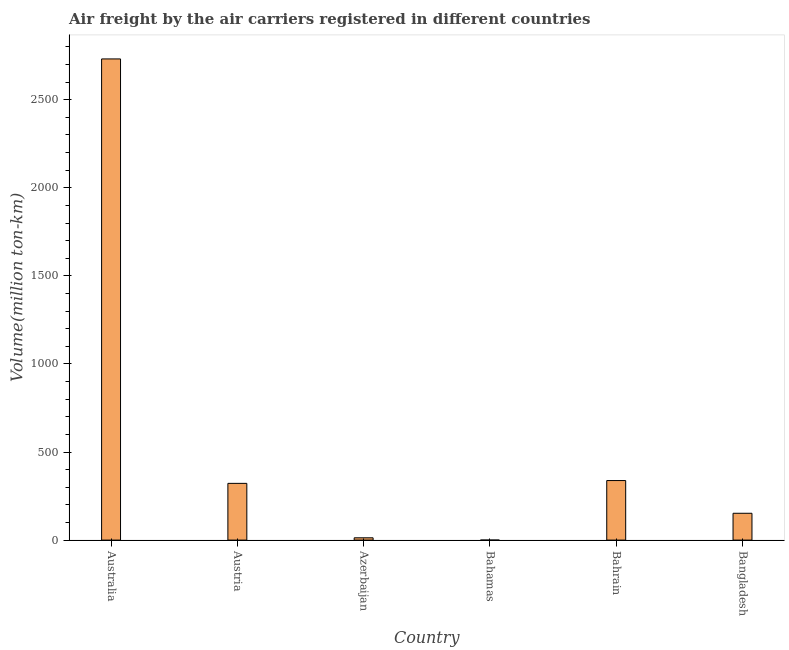Does the graph contain any zero values?
Ensure brevity in your answer.  No. What is the title of the graph?
Your response must be concise. Air freight by the air carriers registered in different countries. What is the label or title of the X-axis?
Offer a very short reply. Country. What is the label or title of the Y-axis?
Your answer should be very brief. Volume(million ton-km). What is the air freight in Azerbaijan?
Your response must be concise. 13.04. Across all countries, what is the maximum air freight?
Offer a terse response. 2731.7. Across all countries, what is the minimum air freight?
Make the answer very short. 0.12. In which country was the air freight maximum?
Provide a short and direct response. Australia. In which country was the air freight minimum?
Offer a very short reply. Bahamas. What is the sum of the air freight?
Your answer should be compact. 3557.36. What is the difference between the air freight in Azerbaijan and Bangladesh?
Your response must be concise. -139.28. What is the average air freight per country?
Your response must be concise. 592.89. What is the median air freight?
Provide a succinct answer. 237.21. What is the ratio of the air freight in Australia to that in Azerbaijan?
Ensure brevity in your answer.  209.42. Is the air freight in Australia less than that in Bahrain?
Your response must be concise. No. What is the difference between the highest and the second highest air freight?
Make the answer very short. 2393.63. What is the difference between the highest and the lowest air freight?
Make the answer very short. 2731.58. What is the difference between two consecutive major ticks on the Y-axis?
Offer a very short reply. 500. Are the values on the major ticks of Y-axis written in scientific E-notation?
Give a very brief answer. No. What is the Volume(million ton-km) in Australia?
Make the answer very short. 2731.7. What is the Volume(million ton-km) of Austria?
Provide a succinct answer. 322.1. What is the Volume(million ton-km) of Azerbaijan?
Provide a succinct answer. 13.04. What is the Volume(million ton-km) in Bahamas?
Offer a very short reply. 0.12. What is the Volume(million ton-km) of Bahrain?
Offer a terse response. 338.07. What is the Volume(million ton-km) of Bangladesh?
Your answer should be very brief. 152.32. What is the difference between the Volume(million ton-km) in Australia and Austria?
Your answer should be compact. 2409.59. What is the difference between the Volume(million ton-km) in Australia and Azerbaijan?
Make the answer very short. 2718.65. What is the difference between the Volume(million ton-km) in Australia and Bahamas?
Give a very brief answer. 2731.58. What is the difference between the Volume(million ton-km) in Australia and Bahrain?
Keep it short and to the point. 2393.63. What is the difference between the Volume(million ton-km) in Australia and Bangladesh?
Provide a succinct answer. 2579.38. What is the difference between the Volume(million ton-km) in Austria and Azerbaijan?
Your answer should be compact. 309.06. What is the difference between the Volume(million ton-km) in Austria and Bahamas?
Your response must be concise. 321.98. What is the difference between the Volume(million ton-km) in Austria and Bahrain?
Provide a short and direct response. -15.97. What is the difference between the Volume(million ton-km) in Austria and Bangladesh?
Your answer should be compact. 169.78. What is the difference between the Volume(million ton-km) in Azerbaijan and Bahamas?
Your answer should be very brief. 12.92. What is the difference between the Volume(million ton-km) in Azerbaijan and Bahrain?
Your answer should be very brief. -325.03. What is the difference between the Volume(million ton-km) in Azerbaijan and Bangladesh?
Your answer should be very brief. -139.27. What is the difference between the Volume(million ton-km) in Bahamas and Bahrain?
Make the answer very short. -337.95. What is the difference between the Volume(million ton-km) in Bahamas and Bangladesh?
Keep it short and to the point. -152.2. What is the difference between the Volume(million ton-km) in Bahrain and Bangladesh?
Your response must be concise. 185.75. What is the ratio of the Volume(million ton-km) in Australia to that in Austria?
Provide a succinct answer. 8.48. What is the ratio of the Volume(million ton-km) in Australia to that in Azerbaijan?
Your response must be concise. 209.42. What is the ratio of the Volume(million ton-km) in Australia to that in Bahamas?
Your answer should be very brief. 2.27e+04. What is the ratio of the Volume(million ton-km) in Australia to that in Bahrain?
Ensure brevity in your answer.  8.08. What is the ratio of the Volume(million ton-km) in Australia to that in Bangladesh?
Give a very brief answer. 17.93. What is the ratio of the Volume(million ton-km) in Austria to that in Azerbaijan?
Make the answer very short. 24.69. What is the ratio of the Volume(million ton-km) in Austria to that in Bahamas?
Make the answer very short. 2681.89. What is the ratio of the Volume(million ton-km) in Austria to that in Bahrain?
Offer a terse response. 0.95. What is the ratio of the Volume(million ton-km) in Austria to that in Bangladesh?
Your response must be concise. 2.12. What is the ratio of the Volume(million ton-km) in Azerbaijan to that in Bahamas?
Make the answer very short. 108.61. What is the ratio of the Volume(million ton-km) in Azerbaijan to that in Bahrain?
Offer a terse response. 0.04. What is the ratio of the Volume(million ton-km) in Azerbaijan to that in Bangladesh?
Offer a terse response. 0.09. What is the ratio of the Volume(million ton-km) in Bahamas to that in Bangladesh?
Provide a short and direct response. 0. What is the ratio of the Volume(million ton-km) in Bahrain to that in Bangladesh?
Offer a terse response. 2.22. 